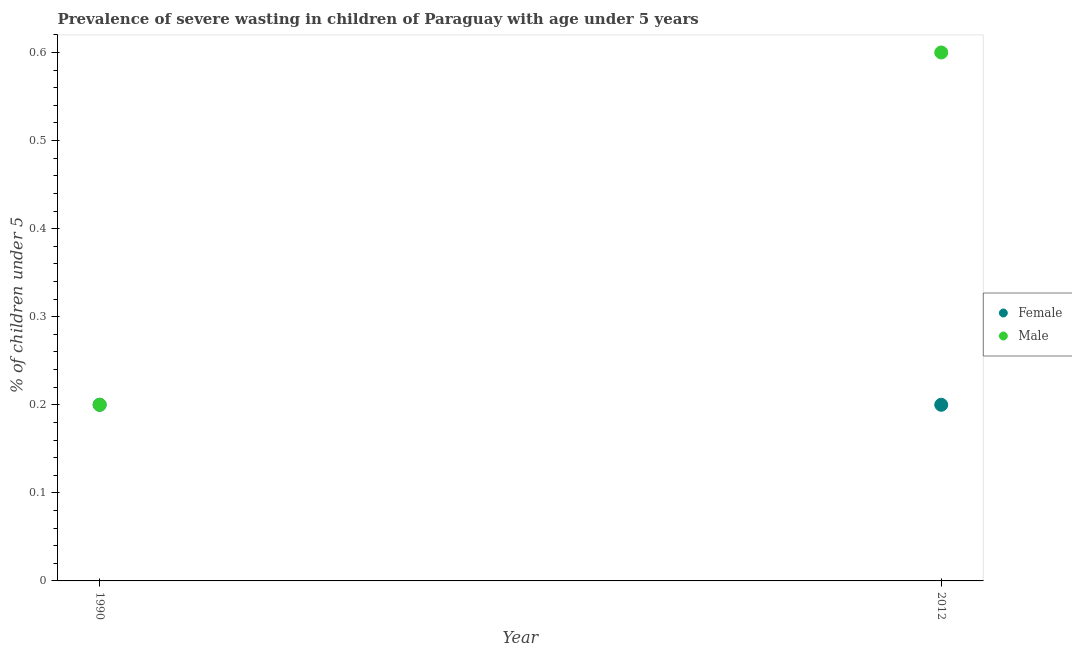Is the number of dotlines equal to the number of legend labels?
Ensure brevity in your answer.  Yes. What is the percentage of undernourished female children in 1990?
Keep it short and to the point. 0.2. Across all years, what is the maximum percentage of undernourished male children?
Provide a succinct answer. 0.6. Across all years, what is the minimum percentage of undernourished male children?
Provide a succinct answer. 0.2. In which year was the percentage of undernourished male children maximum?
Give a very brief answer. 2012. In which year was the percentage of undernourished female children minimum?
Your response must be concise. 1990. What is the total percentage of undernourished male children in the graph?
Provide a short and direct response. 0.8. What is the difference between the percentage of undernourished female children in 1990 and that in 2012?
Ensure brevity in your answer.  0. What is the average percentage of undernourished male children per year?
Provide a short and direct response. 0.4. In the year 2012, what is the difference between the percentage of undernourished female children and percentage of undernourished male children?
Ensure brevity in your answer.  -0.4. In how many years, is the percentage of undernourished male children greater than the average percentage of undernourished male children taken over all years?
Ensure brevity in your answer.  1. Does the percentage of undernourished male children monotonically increase over the years?
Ensure brevity in your answer.  Yes. Is the percentage of undernourished male children strictly greater than the percentage of undernourished female children over the years?
Offer a terse response. No. Is the percentage of undernourished female children strictly less than the percentage of undernourished male children over the years?
Your answer should be compact. No. How many years are there in the graph?
Offer a very short reply. 2. Are the values on the major ticks of Y-axis written in scientific E-notation?
Offer a terse response. No. Does the graph contain any zero values?
Keep it short and to the point. No. Does the graph contain grids?
Your answer should be very brief. No. What is the title of the graph?
Provide a succinct answer. Prevalence of severe wasting in children of Paraguay with age under 5 years. Does "Import" appear as one of the legend labels in the graph?
Provide a short and direct response. No. What is the label or title of the X-axis?
Ensure brevity in your answer.  Year. What is the label or title of the Y-axis?
Ensure brevity in your answer.   % of children under 5. What is the  % of children under 5 in Female in 1990?
Your answer should be very brief. 0.2. What is the  % of children under 5 of Male in 1990?
Provide a succinct answer. 0.2. What is the  % of children under 5 of Female in 2012?
Ensure brevity in your answer.  0.2. What is the  % of children under 5 in Male in 2012?
Your answer should be compact. 0.6. Across all years, what is the maximum  % of children under 5 in Female?
Offer a terse response. 0.2. Across all years, what is the maximum  % of children under 5 in Male?
Your answer should be very brief. 0.6. Across all years, what is the minimum  % of children under 5 in Female?
Offer a terse response. 0.2. Across all years, what is the minimum  % of children under 5 of Male?
Keep it short and to the point. 0.2. What is the total  % of children under 5 of Female in the graph?
Keep it short and to the point. 0.4. What is the difference between the  % of children under 5 of Female in 1990 and that in 2012?
Give a very brief answer. 0. What is the difference between the  % of children under 5 of Male in 1990 and that in 2012?
Ensure brevity in your answer.  -0.4. What is the difference between the  % of children under 5 of Female in 1990 and the  % of children under 5 of Male in 2012?
Your answer should be compact. -0.4. In the year 1990, what is the difference between the  % of children under 5 of Female and  % of children under 5 of Male?
Make the answer very short. 0. What is the ratio of the  % of children under 5 of Female in 1990 to that in 2012?
Offer a very short reply. 1. What is the ratio of the  % of children under 5 in Male in 1990 to that in 2012?
Give a very brief answer. 0.33. What is the difference between the highest and the lowest  % of children under 5 of Female?
Offer a terse response. 0. 